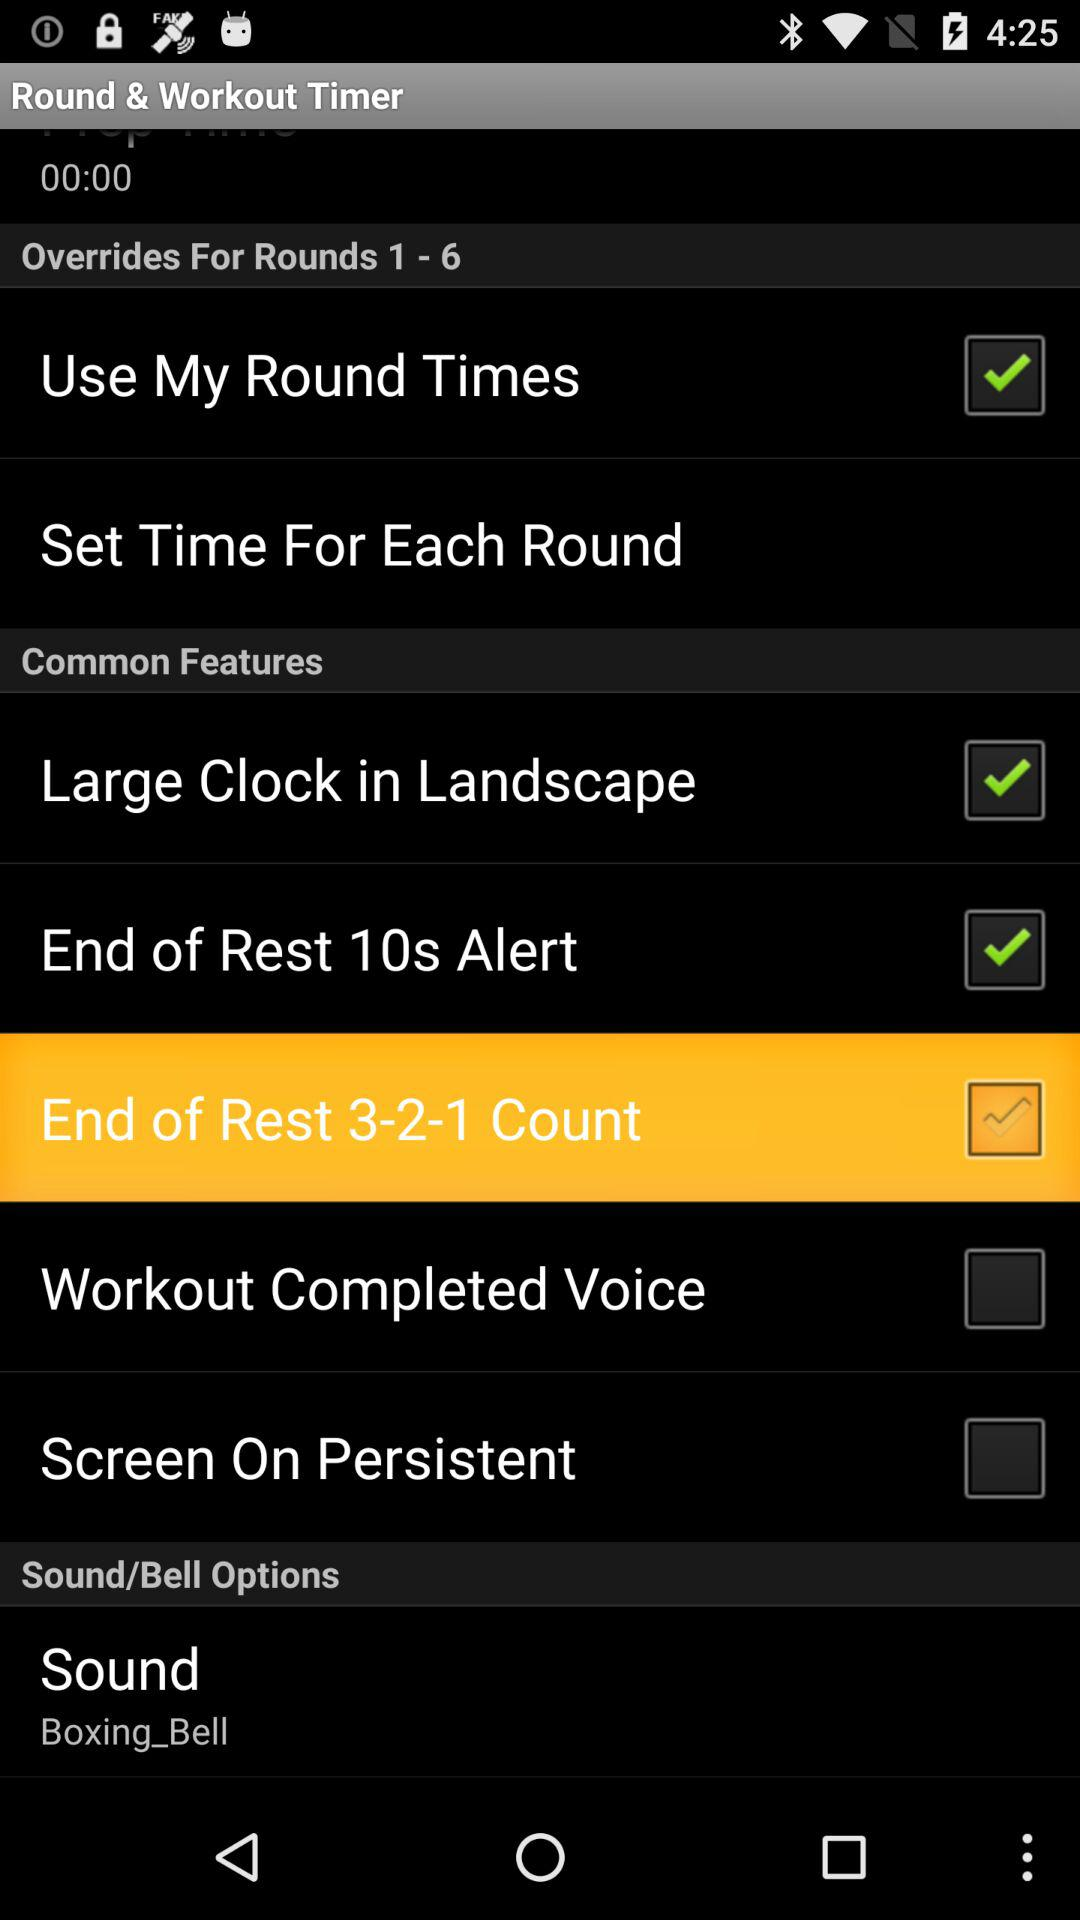What is the status of the "Large Clock in Landscape"? The status is "on". 